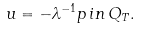Convert formula to latex. <formula><loc_0><loc_0><loc_500><loc_500>u = - \lambda ^ { - 1 } p \, i n \, Q _ { T } .</formula> 